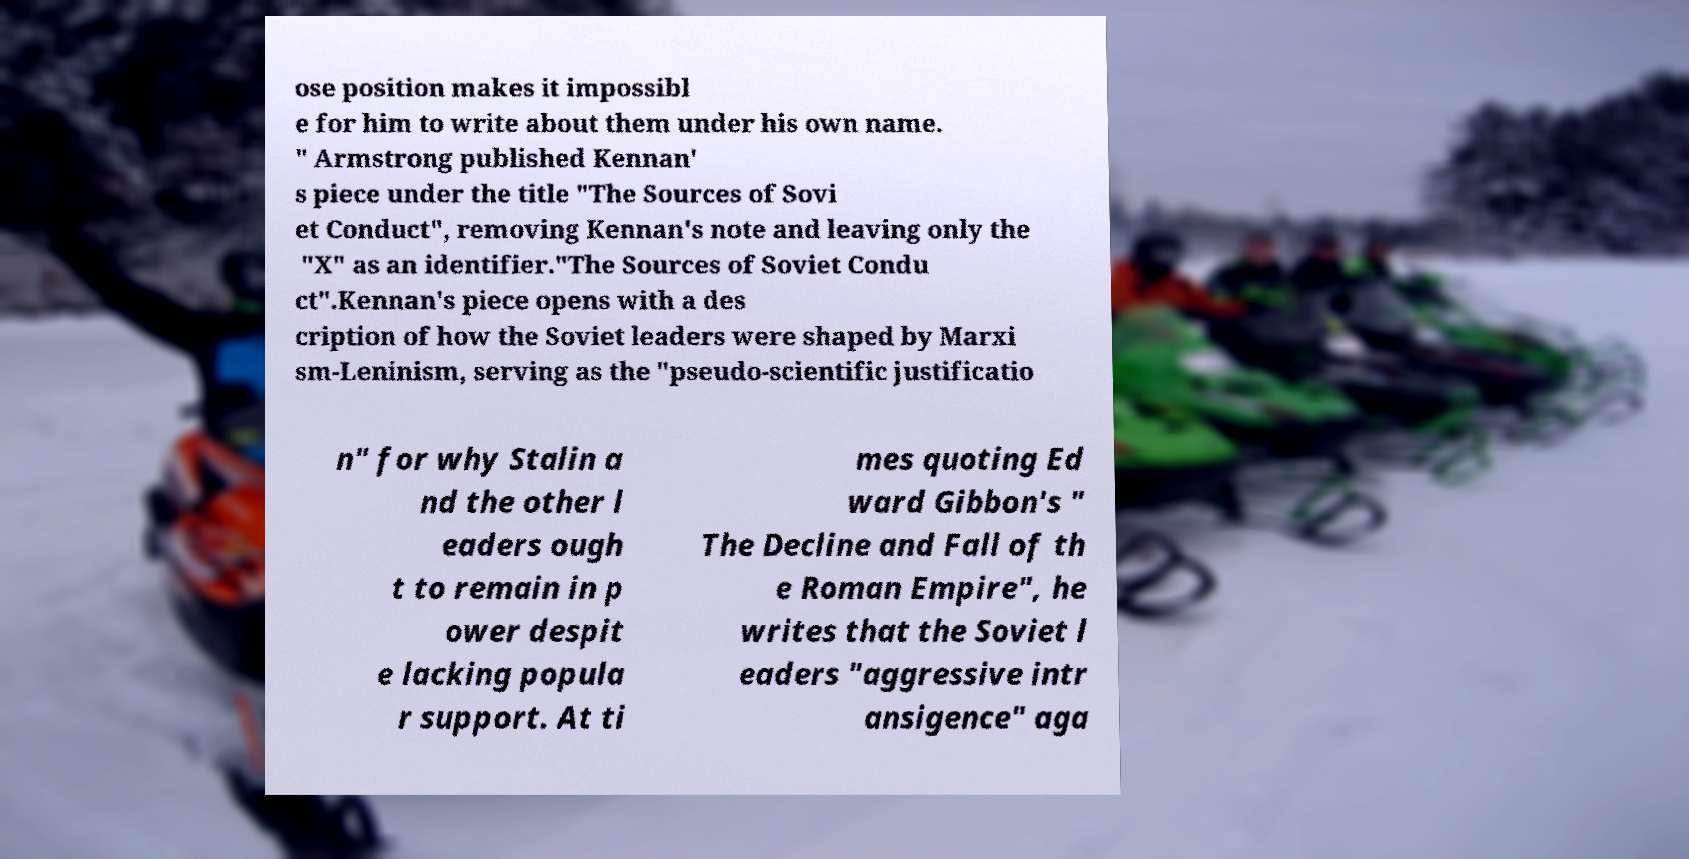Please read and relay the text visible in this image. What does it say? ose position makes it impossibl e for him to write about them under his own name. " Armstrong published Kennan' s piece under the title "The Sources of Sovi et Conduct", removing Kennan's note and leaving only the "X" as an identifier."The Sources of Soviet Condu ct".Kennan's piece opens with a des cription of how the Soviet leaders were shaped by Marxi sm-Leninism, serving as the "pseudo-scientific justificatio n" for why Stalin a nd the other l eaders ough t to remain in p ower despit e lacking popula r support. At ti mes quoting Ed ward Gibbon's " The Decline and Fall of th e Roman Empire", he writes that the Soviet l eaders "aggressive intr ansigence" aga 